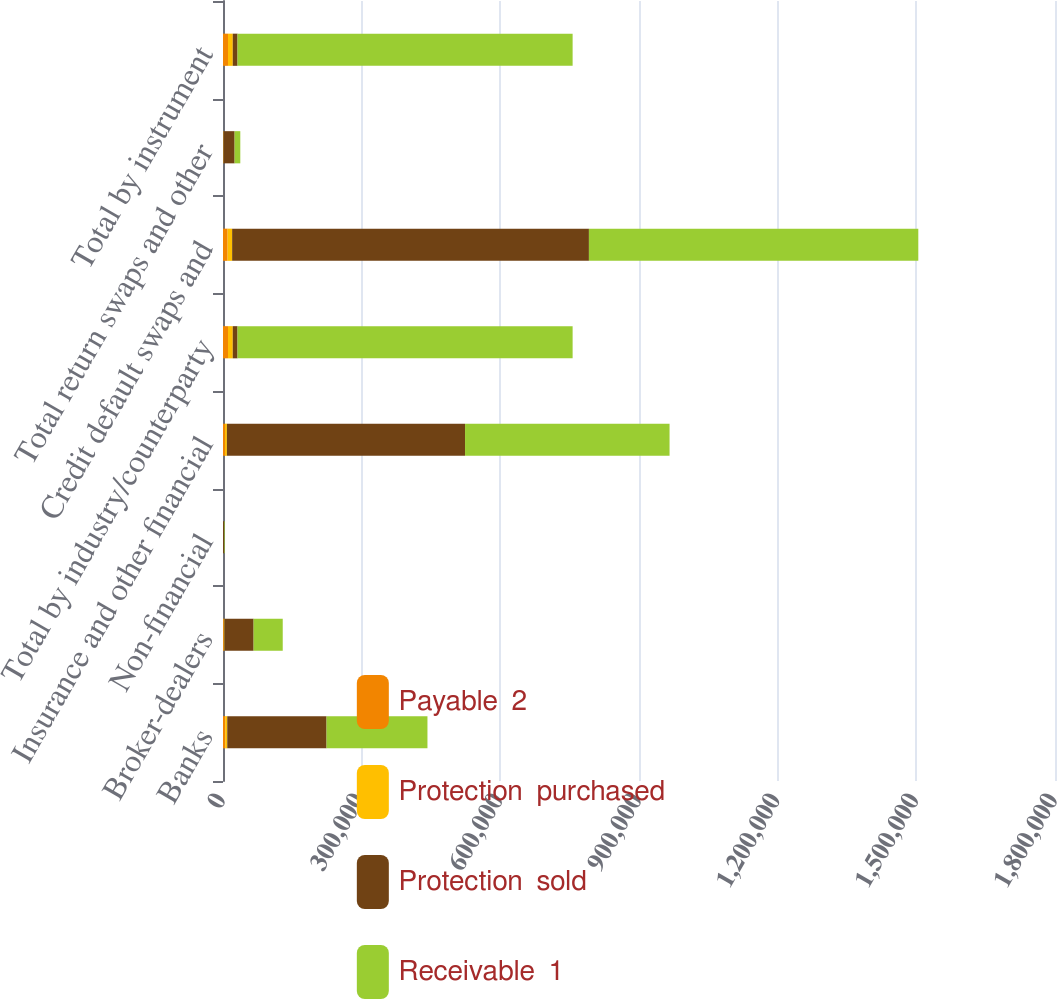Convert chart. <chart><loc_0><loc_0><loc_500><loc_500><stacked_bar_chart><ecel><fcel>Banks<fcel>Broker-dealers<fcel>Non-financial<fcel>Insurance and other financial<fcel>Total by industry/counterparty<fcel>Credit default swaps and<fcel>Total return swaps and other<fcel>Total by instrument<nl><fcel>Payable  2<fcel>4785<fcel>1706<fcel>64<fcel>4210<fcel>10765<fcel>10030<fcel>735<fcel>10765<nl><fcel>Protection  purchased<fcel>4432<fcel>1612<fcel>87<fcel>4220<fcel>10351<fcel>9755<fcel>596<fcel>10351<nl><fcel>Protection  sold<fcel>214842<fcel>62904<fcel>2687<fcel>515216<fcel>10351<fcel>771865<fcel>23784<fcel>10351<nl><fcel>Receivable  1<fcel>218273<fcel>63014<fcel>1192<fcel>442460<fcel>724939<fcel>712623<fcel>12316<fcel>724939<nl></chart> 